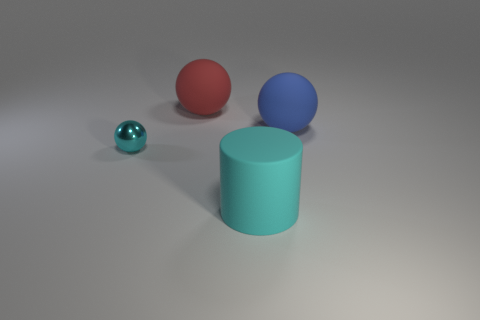Subtract all blue balls. How many balls are left? 2 Subtract all cyan spheres. How many spheres are left? 2 Subtract all green spheres. How many blue cylinders are left? 0 Add 1 cyan shiny things. How many objects exist? 5 Subtract 1 cylinders. How many cylinders are left? 0 Subtract 0 green cubes. How many objects are left? 4 Subtract all balls. How many objects are left? 1 Subtract all blue cylinders. Subtract all red spheres. How many cylinders are left? 1 Subtract all purple matte cylinders. Subtract all tiny cyan metallic balls. How many objects are left? 3 Add 4 large cyan matte things. How many large cyan matte things are left? 5 